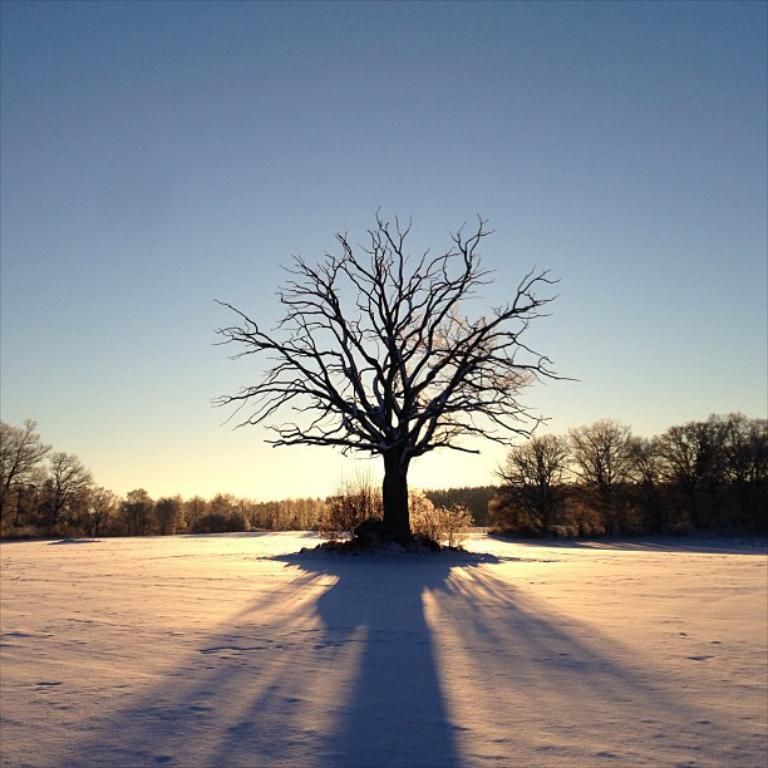What type of vegetation can be seen in the image? There are trees in the image. What else can be seen in the image besides the trees? There is a shadow and the sky visible in the image. What type of advertisement is being displayed on the trees in the image? There is no advertisement present on the trees in the image; it only features trees, a shadow, and the sky. 